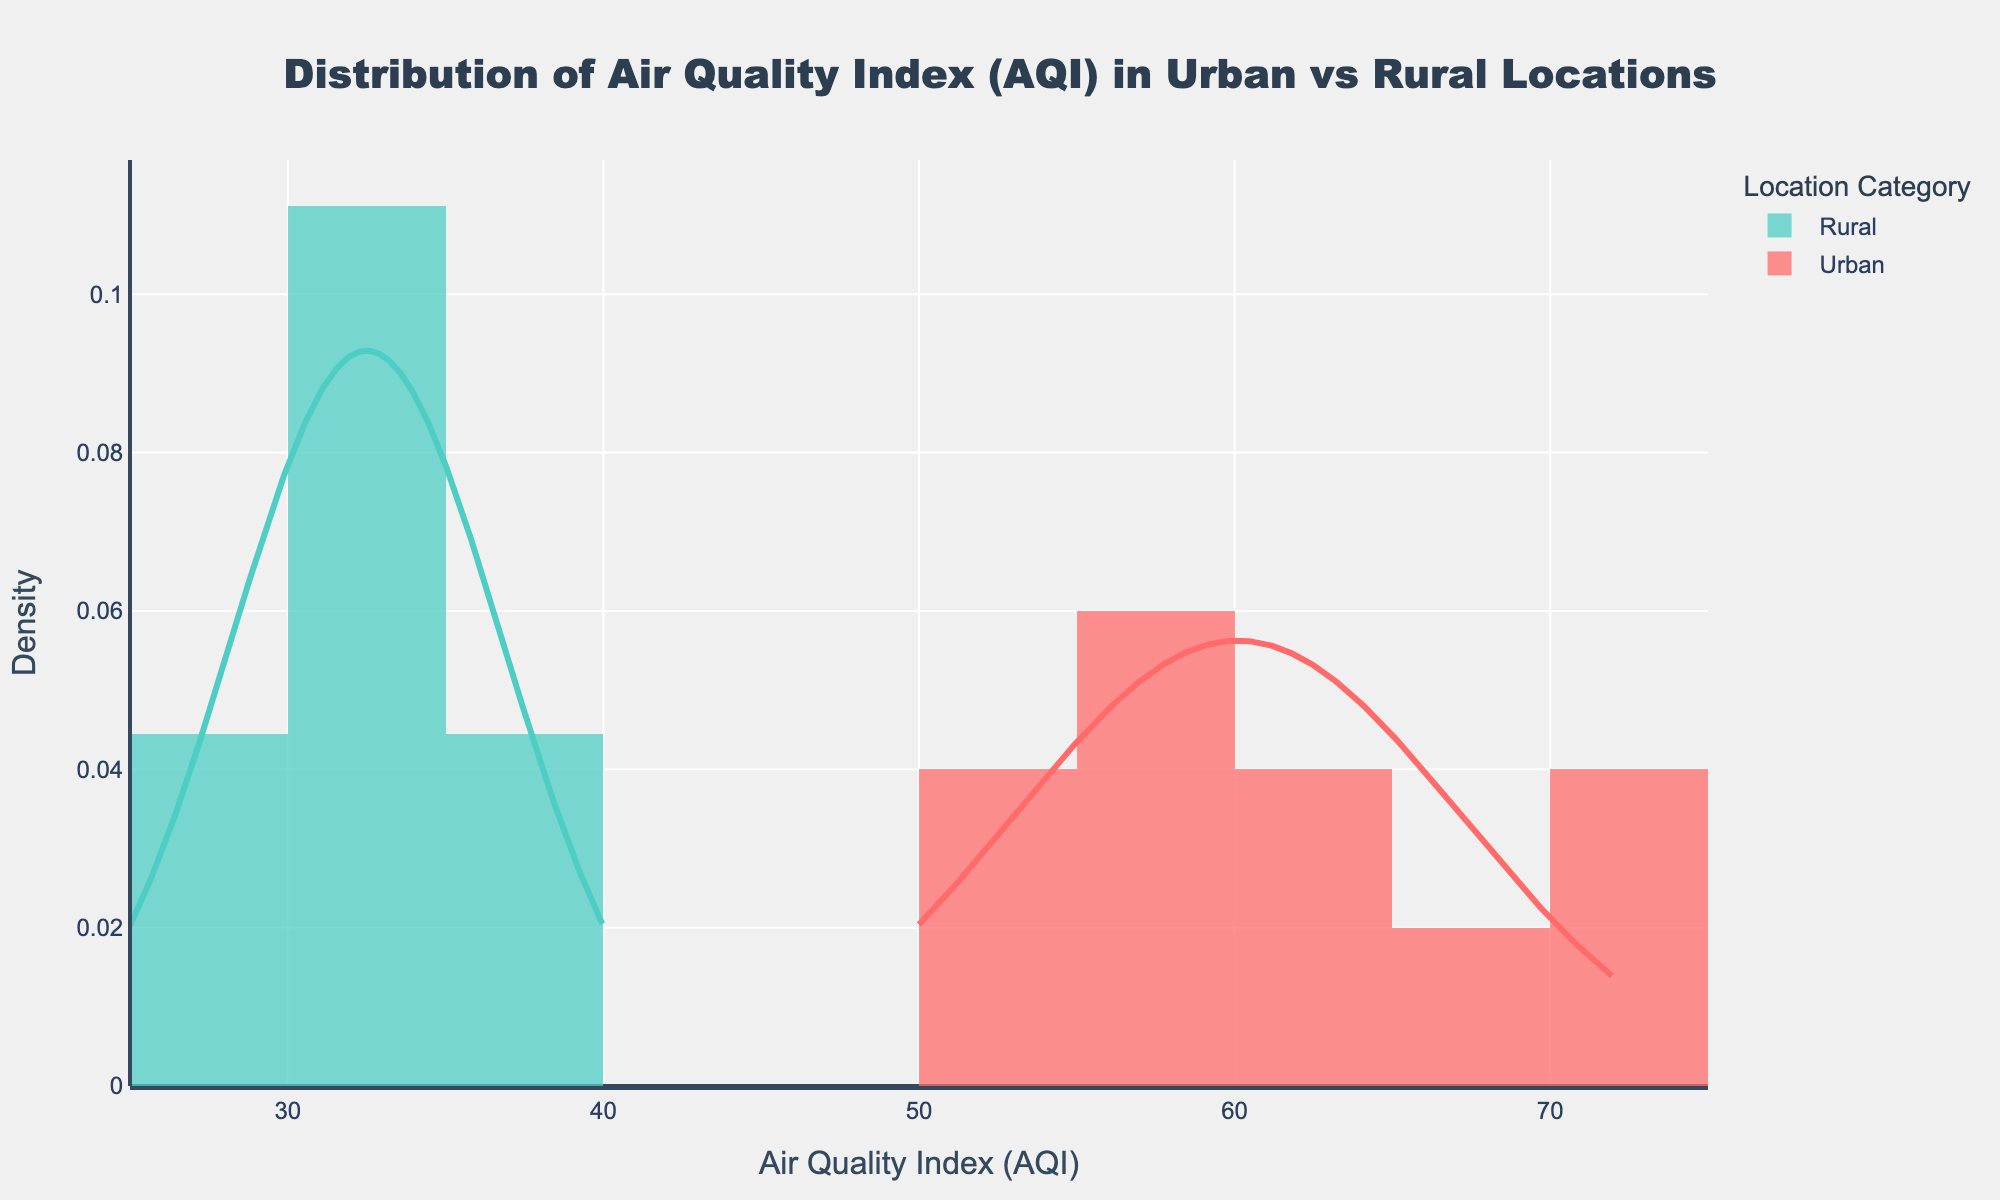What's the title of the plot? The title is located at the top of the plot and provides an overview of what the plot represents. In this case, it reads "Distribution of Air Quality Index (AQI) in Urban vs Rural Locations".
Answer: Distribution of Air Quality Index (AQI) in Urban vs Rural Locations What do the x-axis and y-axis represent? The x-axis represents the Air Quality Index (AQI) values, and the y-axis represents the Density of these values in the given distribution for both urban and rural locations.
Answer: AQI and Density What colors represent urban and rural locations? The colors used in the plot legend indicate that urban locations are represented by red and rural locations by teal. You can infer this from the color labels on the histogram and the corresponding density curves.
Answer: Red for urban and teal for rural What is the approximate peak density value for urban locations? To find this, look at the highest point of the red curve, which represents urban locations. The peak density for urban locations is slightly below 0.1 on the y-axis.
Answer: Approximately 0.1 Which location category has a higher mean AQI value? To determine this, observe the central tendency of the curves. The red curve (urban) appears to be shifted to the right compared to the teal curve (rural), indicating that urban locations have higher AQI values on average.
Answer: Urban Which location category exhibits greater spread in AQI values? By visually examining the width of the distributions, the red curve (urban) is more spread out compared to the teal curve (rural), suggesting that urban locations have more variability in AQI values.
Answer: Urban Estimate the AQI range where rural locations have the highest density. Observe the peak of the teal curve, which is between approximately 25 and 35 on the x-axis, indicating that the highest density of AQI values for rural locations falls within this range.
Answer: Between 25 and 35 Is there any overlap in AQI values between urban and rural locations? Look at where the red and teal curves intersect or nearly intersect. Both curves overlap significantly between AQI values of 50 and 60, implying both urban and rural locations share some AQI values in this range.
Answer: Yes, between 50 and 60 Is the AQI distribution for any location category approximately normal? Check the shapes of the density curves against the typical bell curve of a normal distribution. Both urban and rural distribution curves approach a bell shape, but the urban distribution, in particular, appears closer to a normal distribution.
Answer: Yes, more so for urban locations 